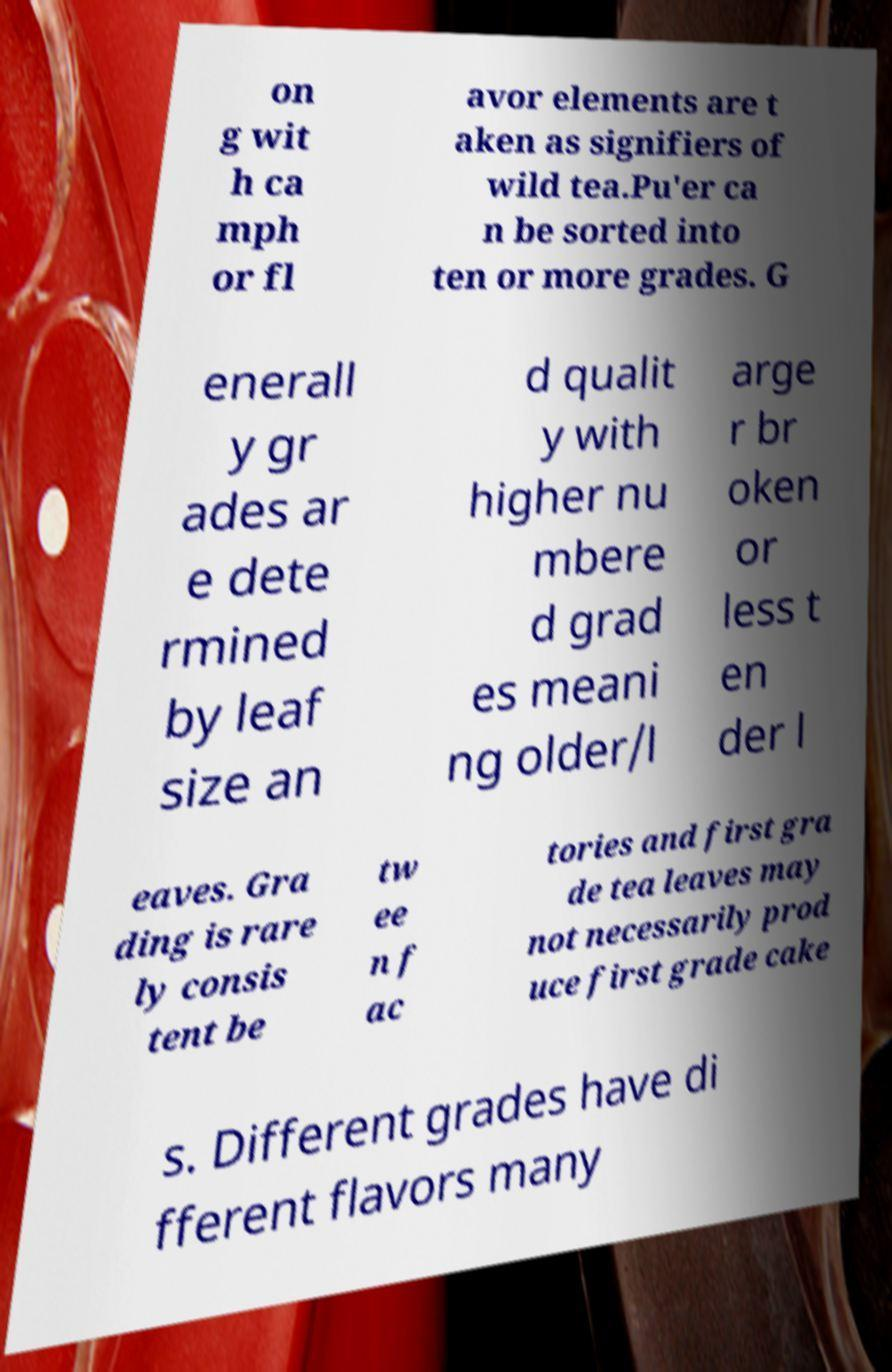What messages or text are displayed in this image? I need them in a readable, typed format. on g wit h ca mph or fl avor elements are t aken as signifiers of wild tea.Pu'er ca n be sorted into ten or more grades. G enerall y gr ades ar e dete rmined by leaf size an d qualit y with higher nu mbere d grad es meani ng older/l arge r br oken or less t en der l eaves. Gra ding is rare ly consis tent be tw ee n f ac tories and first gra de tea leaves may not necessarily prod uce first grade cake s. Different grades have di fferent flavors many 